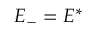<formula> <loc_0><loc_0><loc_500><loc_500>E _ { - } = E ^ { * }</formula> 